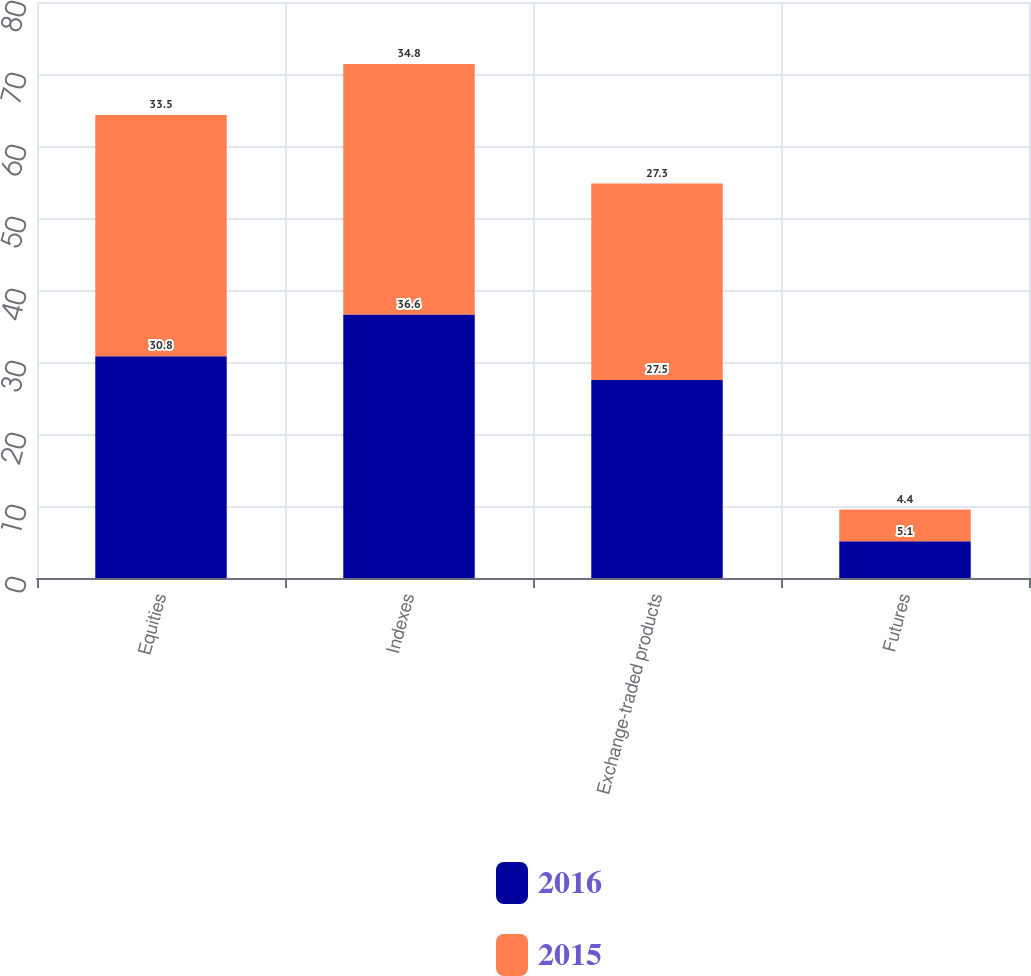Convert chart. <chart><loc_0><loc_0><loc_500><loc_500><stacked_bar_chart><ecel><fcel>Equities<fcel>Indexes<fcel>Exchange-traded products<fcel>Futures<nl><fcel>2016<fcel>30.8<fcel>36.6<fcel>27.5<fcel>5.1<nl><fcel>2015<fcel>33.5<fcel>34.8<fcel>27.3<fcel>4.4<nl></chart> 